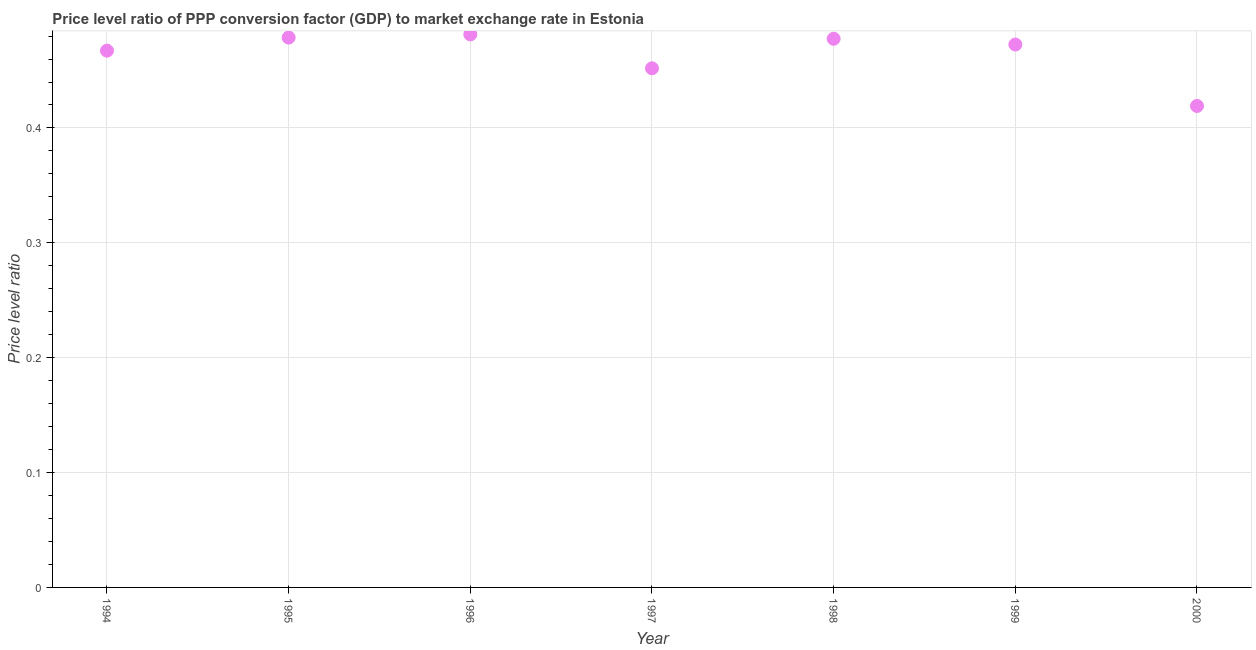What is the price level ratio in 1997?
Your answer should be very brief. 0.45. Across all years, what is the maximum price level ratio?
Your answer should be very brief. 0.48. Across all years, what is the minimum price level ratio?
Provide a short and direct response. 0.42. What is the sum of the price level ratio?
Offer a very short reply. 3.25. What is the difference between the price level ratio in 1998 and 1999?
Make the answer very short. 0.01. What is the average price level ratio per year?
Ensure brevity in your answer.  0.46. What is the median price level ratio?
Offer a very short reply. 0.47. What is the ratio of the price level ratio in 1997 to that in 1998?
Ensure brevity in your answer.  0.95. Is the difference between the price level ratio in 1998 and 2000 greater than the difference between any two years?
Offer a terse response. No. What is the difference between the highest and the second highest price level ratio?
Offer a terse response. 0. What is the difference between the highest and the lowest price level ratio?
Provide a short and direct response. 0.06. In how many years, is the price level ratio greater than the average price level ratio taken over all years?
Provide a succinct answer. 5. Does the price level ratio monotonically increase over the years?
Your answer should be very brief. No. Are the values on the major ticks of Y-axis written in scientific E-notation?
Provide a short and direct response. No. What is the title of the graph?
Provide a succinct answer. Price level ratio of PPP conversion factor (GDP) to market exchange rate in Estonia. What is the label or title of the X-axis?
Provide a short and direct response. Year. What is the label or title of the Y-axis?
Ensure brevity in your answer.  Price level ratio. What is the Price level ratio in 1994?
Your response must be concise. 0.47. What is the Price level ratio in 1995?
Your answer should be compact. 0.48. What is the Price level ratio in 1996?
Make the answer very short. 0.48. What is the Price level ratio in 1997?
Make the answer very short. 0.45. What is the Price level ratio in 1998?
Your answer should be very brief. 0.48. What is the Price level ratio in 1999?
Give a very brief answer. 0.47. What is the Price level ratio in 2000?
Provide a short and direct response. 0.42. What is the difference between the Price level ratio in 1994 and 1995?
Offer a terse response. -0.01. What is the difference between the Price level ratio in 1994 and 1996?
Offer a terse response. -0.01. What is the difference between the Price level ratio in 1994 and 1997?
Ensure brevity in your answer.  0.02. What is the difference between the Price level ratio in 1994 and 1998?
Provide a short and direct response. -0.01. What is the difference between the Price level ratio in 1994 and 1999?
Offer a very short reply. -0.01. What is the difference between the Price level ratio in 1994 and 2000?
Offer a terse response. 0.05. What is the difference between the Price level ratio in 1995 and 1996?
Your answer should be compact. -0. What is the difference between the Price level ratio in 1995 and 1997?
Your answer should be very brief. 0.03. What is the difference between the Price level ratio in 1995 and 1998?
Your answer should be very brief. 0. What is the difference between the Price level ratio in 1995 and 1999?
Your answer should be compact. 0.01. What is the difference between the Price level ratio in 1995 and 2000?
Give a very brief answer. 0.06. What is the difference between the Price level ratio in 1996 and 1997?
Your response must be concise. 0.03. What is the difference between the Price level ratio in 1996 and 1998?
Your response must be concise. 0. What is the difference between the Price level ratio in 1996 and 1999?
Offer a terse response. 0.01. What is the difference between the Price level ratio in 1996 and 2000?
Your response must be concise. 0.06. What is the difference between the Price level ratio in 1997 and 1998?
Give a very brief answer. -0.03. What is the difference between the Price level ratio in 1997 and 1999?
Keep it short and to the point. -0.02. What is the difference between the Price level ratio in 1997 and 2000?
Keep it short and to the point. 0.03. What is the difference between the Price level ratio in 1998 and 1999?
Offer a terse response. 0.01. What is the difference between the Price level ratio in 1998 and 2000?
Offer a very short reply. 0.06. What is the difference between the Price level ratio in 1999 and 2000?
Your response must be concise. 0.05. What is the ratio of the Price level ratio in 1994 to that in 1995?
Provide a short and direct response. 0.98. What is the ratio of the Price level ratio in 1994 to that in 1997?
Your response must be concise. 1.03. What is the ratio of the Price level ratio in 1994 to that in 1998?
Provide a short and direct response. 0.98. What is the ratio of the Price level ratio in 1994 to that in 2000?
Your answer should be compact. 1.11. What is the ratio of the Price level ratio in 1995 to that in 1996?
Keep it short and to the point. 0.99. What is the ratio of the Price level ratio in 1995 to that in 1997?
Provide a succinct answer. 1.06. What is the ratio of the Price level ratio in 1995 to that in 2000?
Provide a short and direct response. 1.14. What is the ratio of the Price level ratio in 1996 to that in 1997?
Provide a short and direct response. 1.06. What is the ratio of the Price level ratio in 1996 to that in 1999?
Make the answer very short. 1.02. What is the ratio of the Price level ratio in 1996 to that in 2000?
Make the answer very short. 1.15. What is the ratio of the Price level ratio in 1997 to that in 1998?
Offer a terse response. 0.95. What is the ratio of the Price level ratio in 1997 to that in 1999?
Provide a short and direct response. 0.96. What is the ratio of the Price level ratio in 1997 to that in 2000?
Offer a terse response. 1.08. What is the ratio of the Price level ratio in 1998 to that in 1999?
Offer a terse response. 1.01. What is the ratio of the Price level ratio in 1998 to that in 2000?
Keep it short and to the point. 1.14. What is the ratio of the Price level ratio in 1999 to that in 2000?
Your response must be concise. 1.13. 